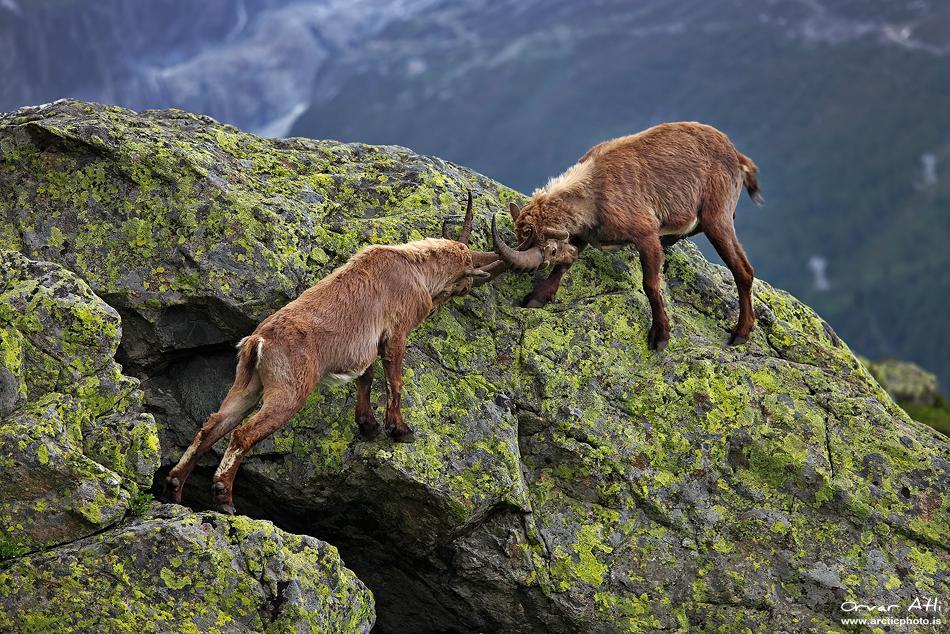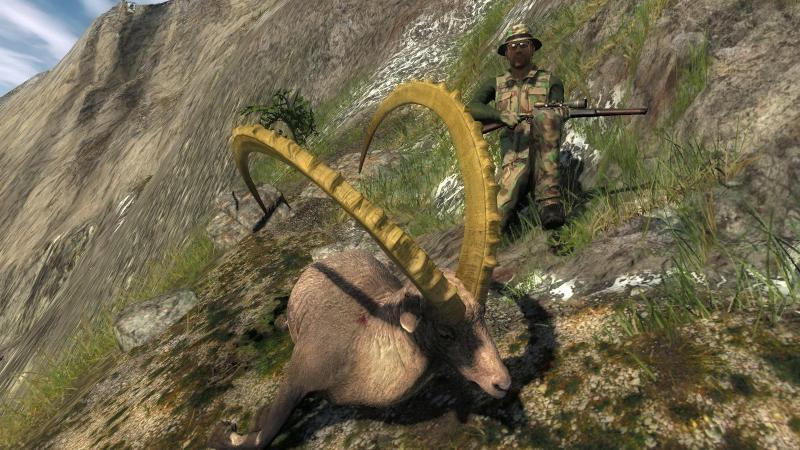The first image is the image on the left, the second image is the image on the right. Considering the images on both sides, is "All images show at least two horned animals in some kind of face-off, and in one image at least one animal has its front legs off the ground." valid? Answer yes or no. No. The first image is the image on the left, the second image is the image on the right. Analyze the images presented: Is the assertion "There are three antelopes on a rocky mountain in the pair of images." valid? Answer yes or no. Yes. 